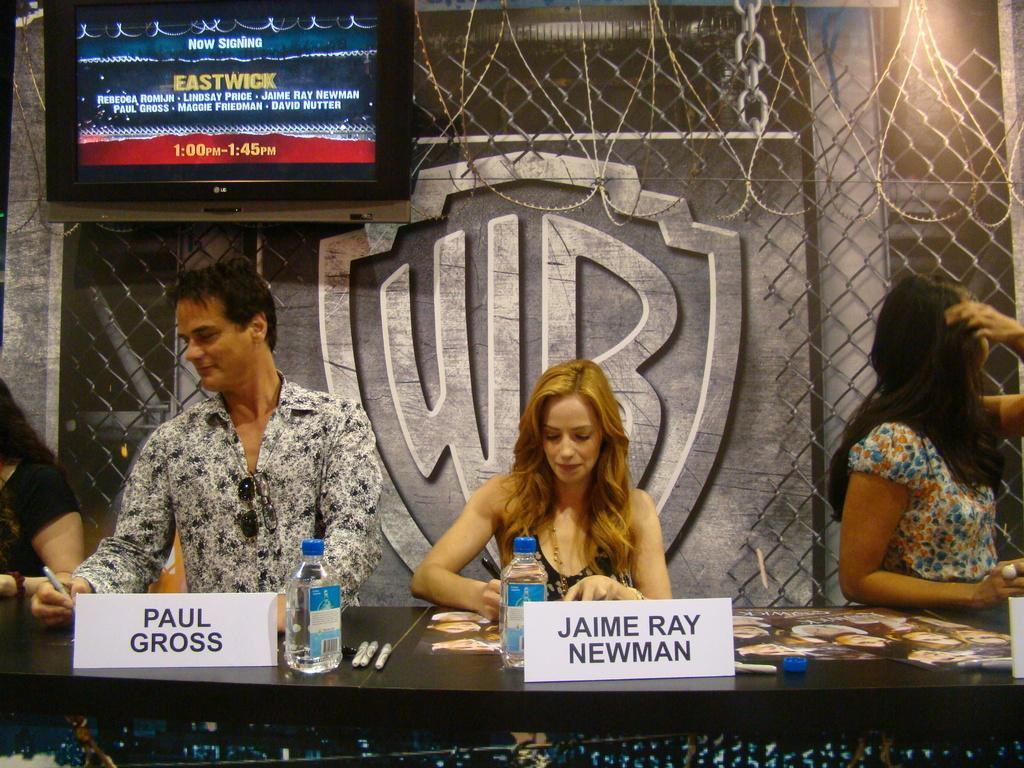In one or two sentences, can you explain what this image depicts? In this image we can see a few people and in front of them there is a table and on the table we can see two water bottles, boards with text and some other objects. In the background we can see a wall with a poster and there is a television. 